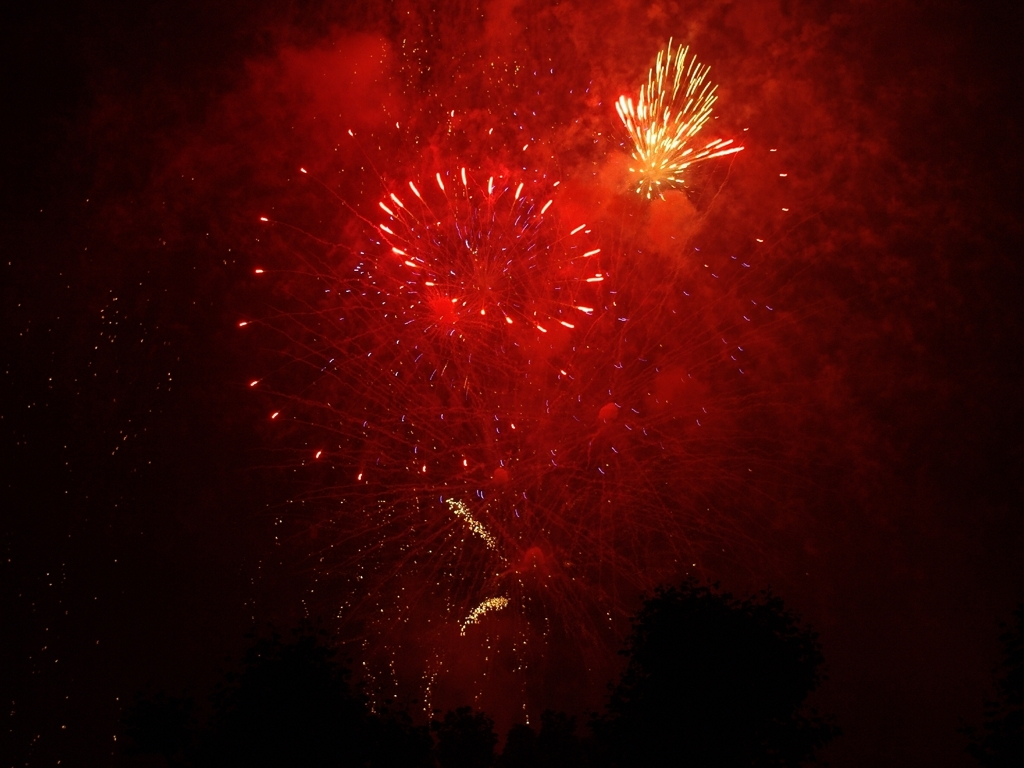Can you speculate on the location where this photo was taken? While the specific location cannot be determined from the fireworks alone, the presence of dense tree silhouettes at the bottom suggests it might be a park or a rural area near a city, chosen for an open view of the sky to accommodate such a dynamic fireworks display. 